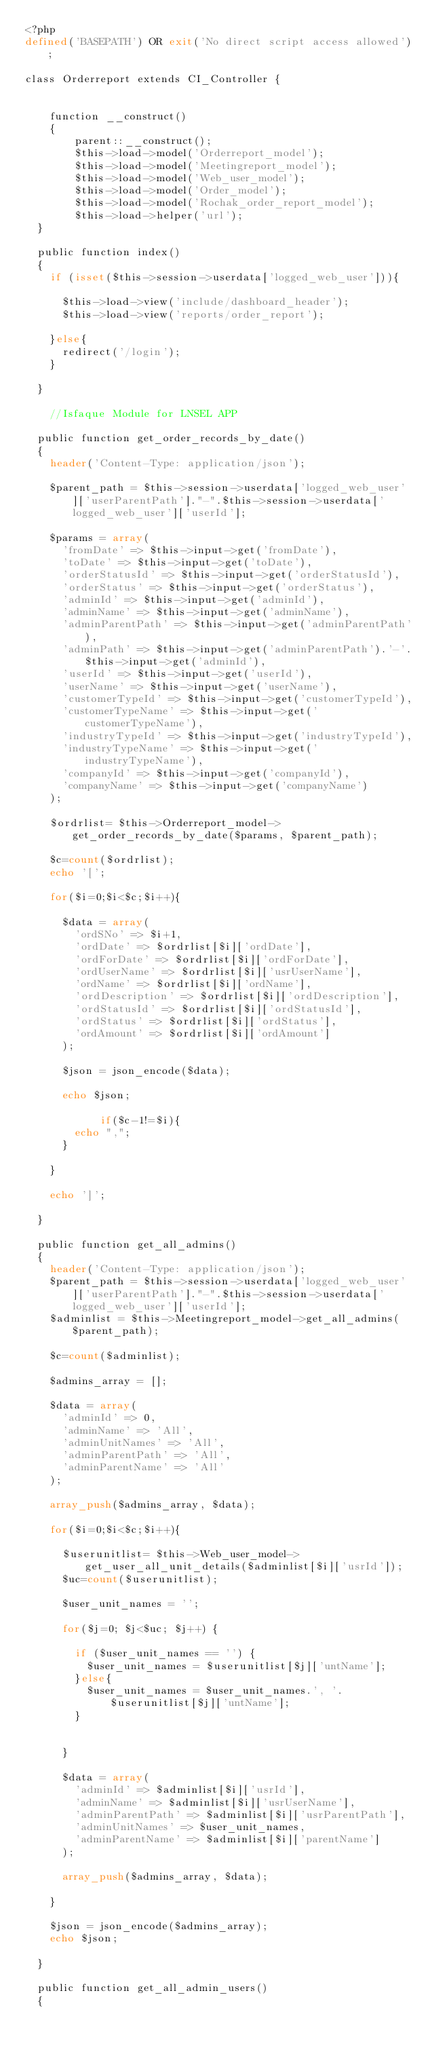Convert code to text. <code><loc_0><loc_0><loc_500><loc_500><_PHP_><?php
defined('BASEPATH') OR exit('No direct script access allowed');

class Orderreport extends CI_Controller {


    function __construct()
    {
        parent::__construct();	
        $this->load->model('Orderreport_model');
        $this->load->model('Meetingreport_model');
        $this->load->model('Web_user_model');
        $this->load->model('Order_model');
        $this->load->model('Rochak_order_report_model');
        $this->load->helper('url');
	} 

	public function index()
	{
		if (isset($this->session->userdata['logged_web_user'])){

			$this->load->view('include/dashboard_header');
			$this->load->view('reports/order_report');

		}else{
			redirect('/login');
		}
		
	}
    
    //Isfaque Module for LNSEL APP
    
	public function get_order_records_by_date()
	{
		header('Content-Type: application/json');

		$parent_path = $this->session->userdata['logged_web_user']['userParentPath']."-".$this->session->userdata['logged_web_user']['userId'];

		$params = array(
			'fromDate' => $this->input->get('fromDate'),
			'toDate' => $this->input->get('toDate'),
			'orderStatusId' => $this->input->get('orderStatusId'),
			'orderStatus' => $this->input->get('orderStatus'),
			'adminId' => $this->input->get('adminId'),
			'adminName' => $this->input->get('adminName'),
			'adminParentPath' => $this->input->get('adminParentPath'),
			'adminPath' => $this->input->get('adminParentPath').'-'.$this->input->get('adminId'),
			'userId' => $this->input->get('userId'),
			'userName' => $this->input->get('userName'),
			'customerTypeId' => $this->input->get('customerTypeId'),
			'customerTypeName' => $this->input->get('customerTypeName'),
			'industryTypeId' => $this->input->get('industryTypeId'),
			'industryTypeName' => $this->input->get('industryTypeName'),
			'companyId' => $this->input->get('companyId'),
			'companyName' => $this->input->get('companyName')
		);

		$ordrlist= $this->Orderreport_model->get_order_records_by_date($params, $parent_path);

		$c=count($ordrlist);
		echo '[';

		for($i=0;$i<$c;$i++){

			$data = array(
				'ordSNo' => $i+1,
				'ordDate' => $ordrlist[$i]['ordDate'],
				'ordForDate' => $ordrlist[$i]['ordForDate'],
				'ordUserName' => $ordrlist[$i]['usrUserName'],
				'ordName' => $ordrlist[$i]['ordName'],
				'ordDescription' => $ordrlist[$i]['ordDescription'],
				'ordStatusId' => $ordrlist[$i]['ordStatusId'],
				'ordStatus' => $ordrlist[$i]['ordStatus'],
				'ordAmount' => $ordrlist[$i]['ordAmount']
			);

			$json = json_encode($data);

			echo $json;

            if($c-1!=$i){
				echo ",";
			}

		}

		echo ']';

	}

	public function get_all_admins()
	{
		header('Content-Type: application/json');
		$parent_path = $this->session->userdata['logged_web_user']['userParentPath']."-".$this->session->userdata['logged_web_user']['userId'];
		$adminlist = $this->Meetingreport_model->get_all_admins($parent_path);

		$c=count($adminlist);

		$admins_array = [];

		$data = array(
			'adminId' => 0,
			'adminName' => 'All',
			'adminUnitNames' => 'All',
			'adminParentPath' => 'All',
			'adminParentName' => 'All'
		);

		array_push($admins_array, $data);

		for($i=0;$i<$c;$i++){

			$userunitlist= $this->Web_user_model->get_user_all_unit_details($adminlist[$i]['usrId']);
			$uc=count($userunitlist);

			$user_unit_names = '';

			for($j=0; $j<$uc; $j++) {

				if ($user_unit_names == '') {
					$user_unit_names = $userunitlist[$j]['untName'];
				}else{
					$user_unit_names = $user_unit_names.', '.$userunitlist[$j]['untName'];
				}
				

			}

			$data = array(
				'adminId' => $adminlist[$i]['usrId'],
				'adminName' => $adminlist[$i]['usrUserName'],
				'adminParentPath' => $adminlist[$i]['usrParentPath'],
				'adminUnitNames' => $user_unit_names,
				'adminParentName' => $adminlist[$i]['parentName']
			);

			array_push($admins_array, $data);

		}

		$json = json_encode($admins_array);
		echo $json;

	}

	public function get_all_admin_users()
	{</code> 